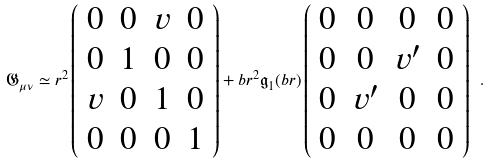<formula> <loc_0><loc_0><loc_500><loc_500>\mathfrak { G } _ { \mu \nu } \simeq r ^ { 2 } \left ( \begin{array} { c c c c } 0 & 0 & v & 0 \\ 0 & 1 & 0 & 0 \\ v & 0 & 1 & 0 \\ 0 & 0 & 0 & 1 \end{array} \right ) + b r ^ { 2 } { \mathfrak g } _ { 1 } ( b r ) \left ( \begin{array} { c c c c } 0 & 0 & 0 & 0 \\ 0 & 0 & v ^ { \prime } & 0 \\ 0 & v ^ { \prime } & 0 & 0 \\ 0 & 0 & 0 & 0 \end{array} \right ) \ .</formula> 